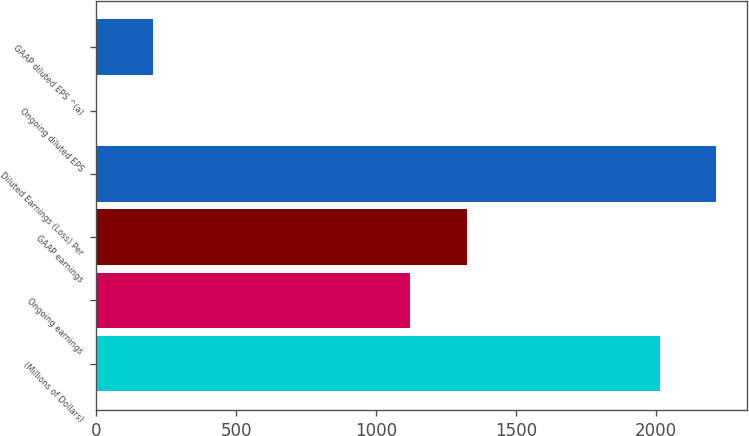Convert chart to OTSL. <chart><loc_0><loc_0><loc_500><loc_500><bar_chart><fcel>(Millions of Dollars)<fcel>Ongoing earnings<fcel>GAAP earnings<fcel>Diluted Earnings (Loss) Per<fcel>Ongoing diluted EPS<fcel>GAAP diluted EPS ^(a)<nl><fcel>2016<fcel>1123.4<fcel>1324.78<fcel>2217.38<fcel>2.21<fcel>203.59<nl></chart> 